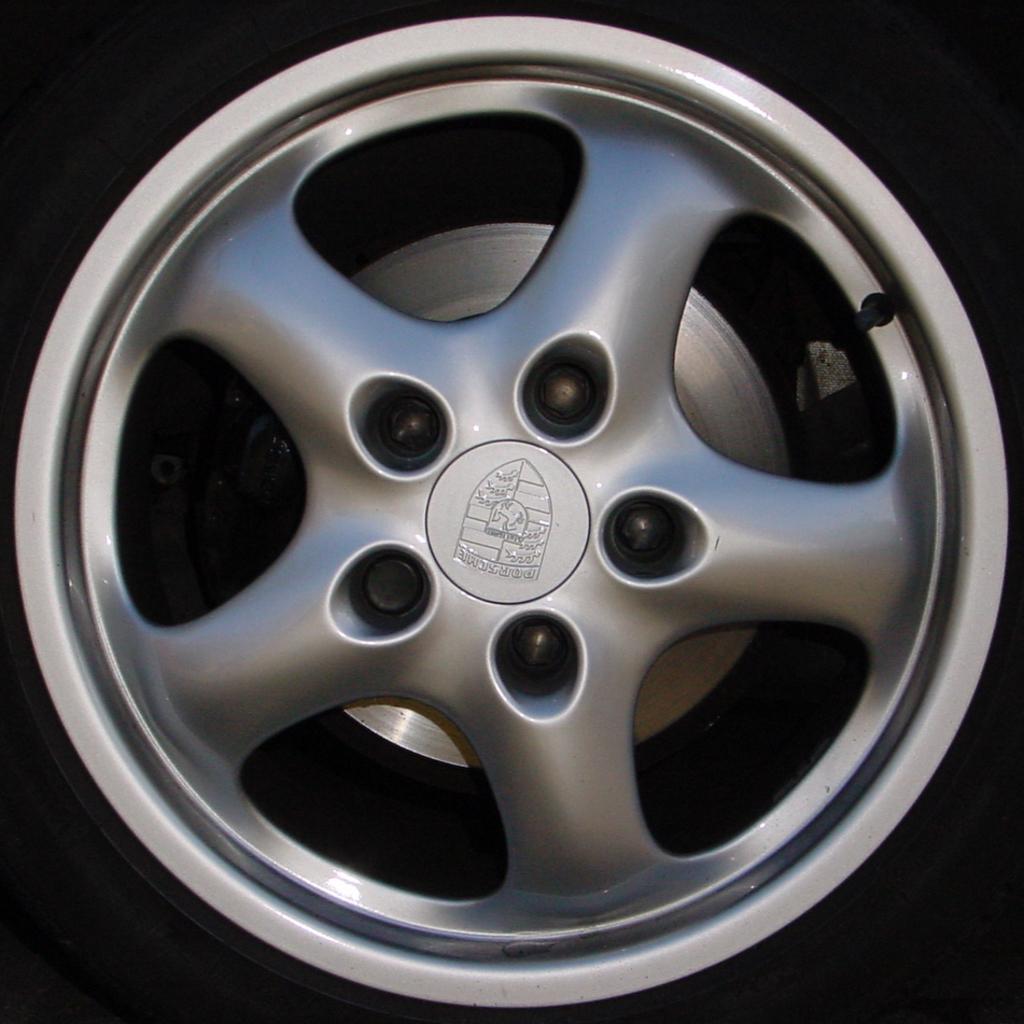In one or two sentences, can you explain what this image depicts? In this image I can see the rim of a vehicle. The background is in black color. 